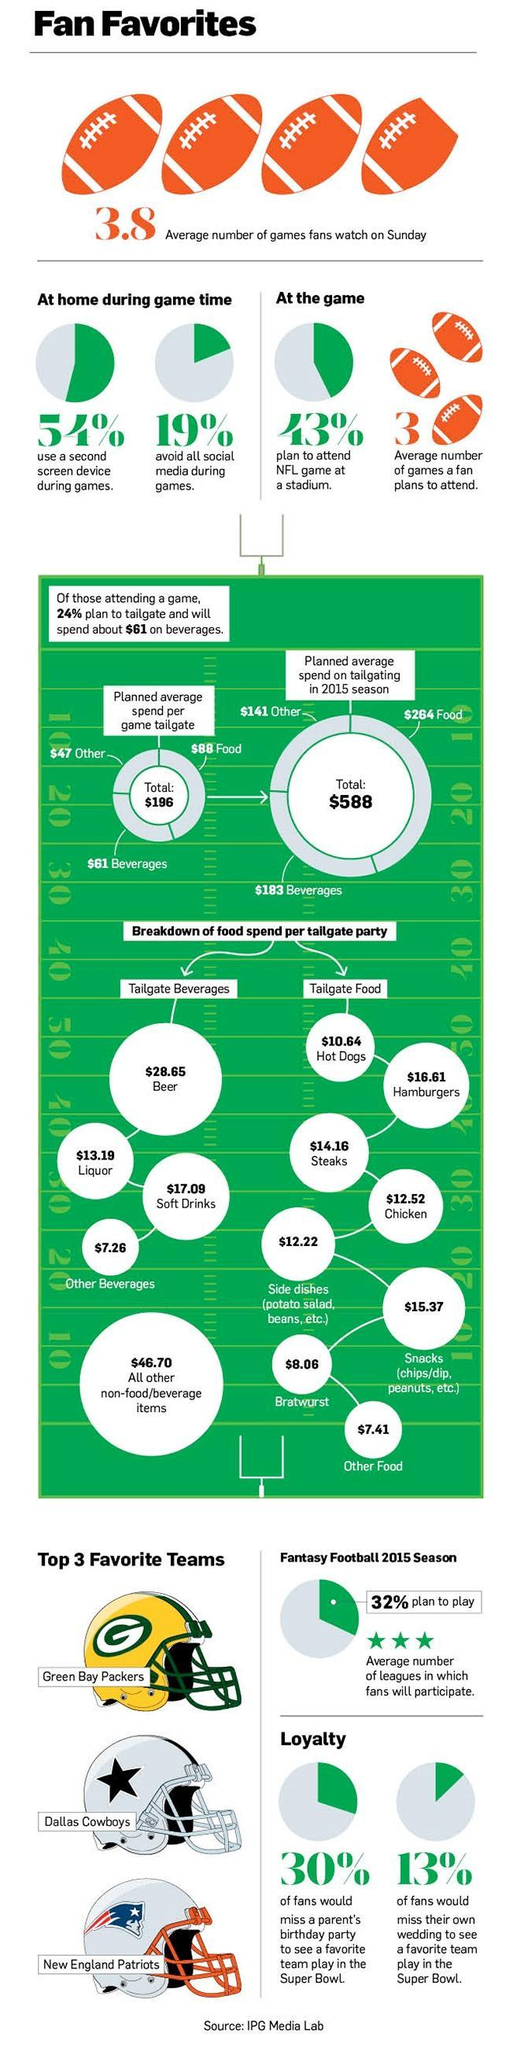what is the total amount spend per delegate party on hot dogs and hamburgers in dollars?
Answer the question with a short phrase. 27.25 what is the total amount spend per delegate party on beer and liquor in dollars? 41.84 what is the total average amount spend on food and beverages in 2015 in dollars? 447 what is the total amount spend per delegate party on steaks and chicken in dollars? 26.68 